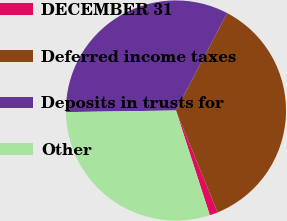Convert chart. <chart><loc_0><loc_0><loc_500><loc_500><pie_chart><fcel>DECEMBER 31<fcel>Deferred income taxes<fcel>Deposits in trusts for<fcel>Other<nl><fcel>1.2%<fcel>36.13%<fcel>32.93%<fcel>29.74%<nl></chart> 